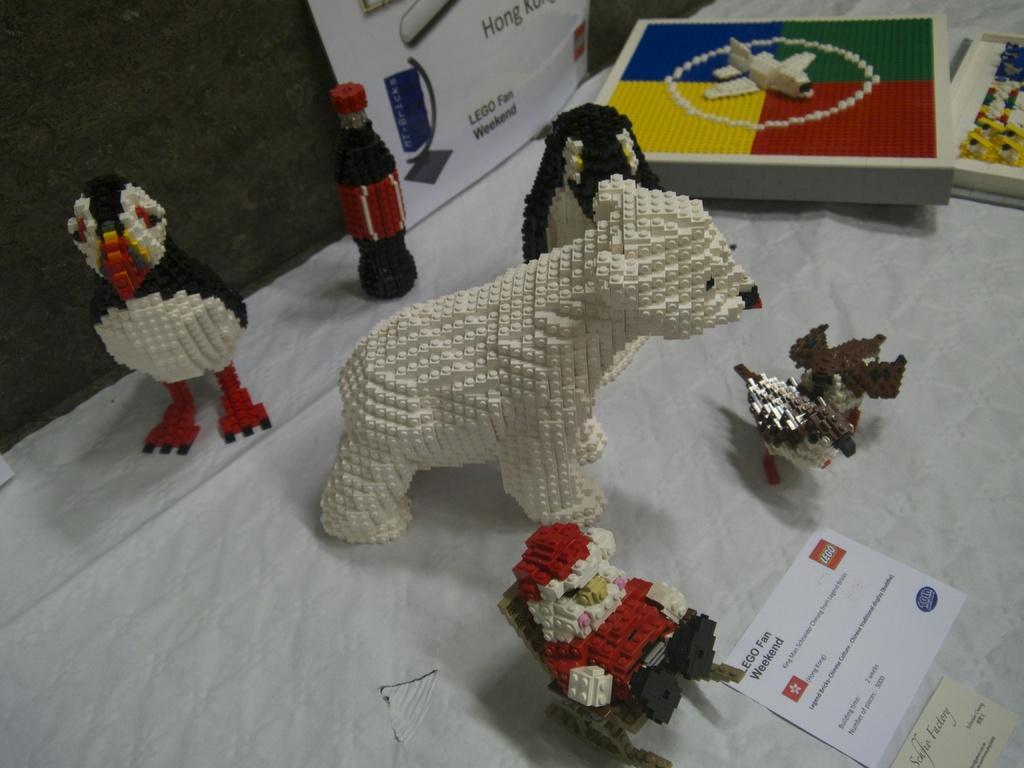Please provide a concise description of this image. Here I can see few toys which are made up of building blocks. Along with the toys I can see two papers. At the top there is a wall to which a white color banner is attached. On the banner, I can see some text. 